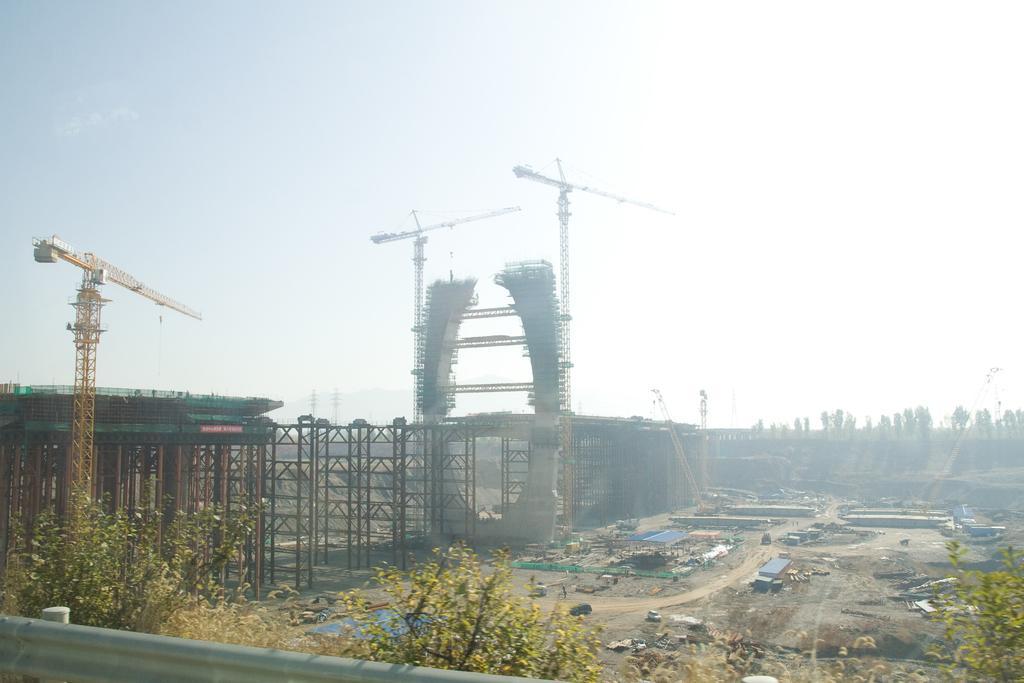How would you summarize this image in a sentence or two? In this image we can see the construction of a structure which looks like a bridge and there are few crane machines. We can see some trees and there are some vehicles and also we can see some objects on the ground and at the top we can see the sky. 